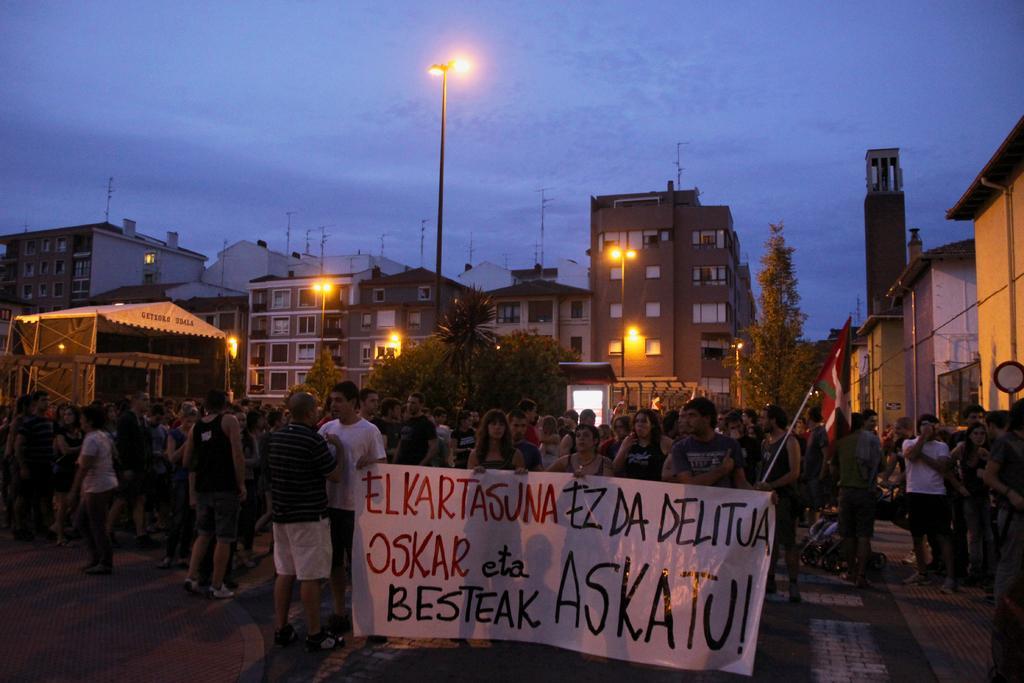Describe this image in one or two sentences. This picture shows few buildings and few people standing and they are holding a banner in their hands and we see a flag and few pole lights and we see trees and a blue cloudy sky. 